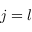<formula> <loc_0><loc_0><loc_500><loc_500>j = l</formula> 